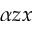<formula> <loc_0><loc_0><loc_500><loc_500>\alpha z x</formula> 